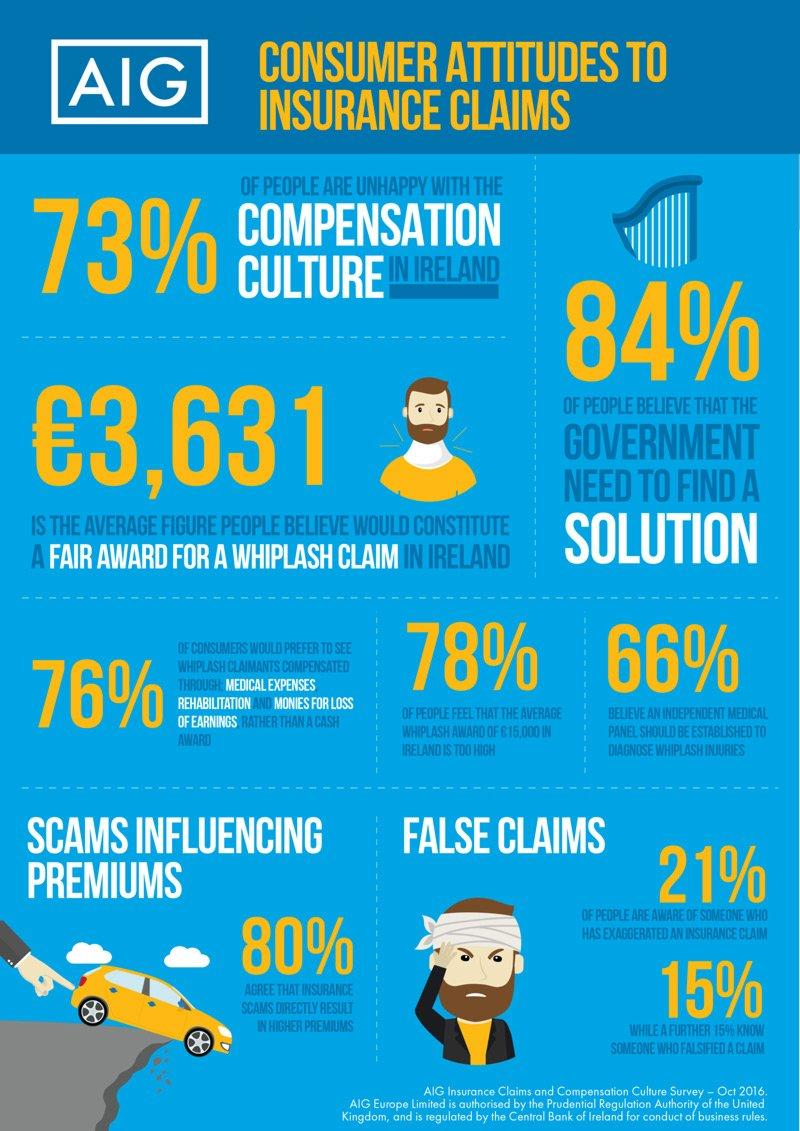Give some essential details in this illustration. According to a survey conducted in October 2016, 78% of people believe that the average whiplash award of €15,000 in Ireland is too much. According to a survey conducted in October 2016, approximately 20% of Irish people do not agree that insurance scams directly result in higher premiums. According to a survey conducted in October 2016, 27% of people in Ireland were satisfied with the compensation culture in the country. 